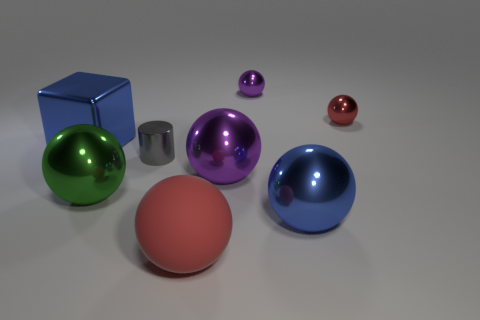Subtract all big green metal balls. How many balls are left? 5 Subtract all brown cylinders. How many purple spheres are left? 2 Subtract all purple spheres. How many spheres are left? 4 Add 1 large things. How many objects exist? 9 Subtract 3 spheres. How many spheres are left? 3 Subtract 0 yellow spheres. How many objects are left? 8 Subtract all blocks. How many objects are left? 7 Subtract all red spheres. Subtract all green cylinders. How many spheres are left? 4 Subtract all big blue balls. Subtract all big yellow shiny things. How many objects are left? 7 Add 5 green shiny spheres. How many green shiny spheres are left? 6 